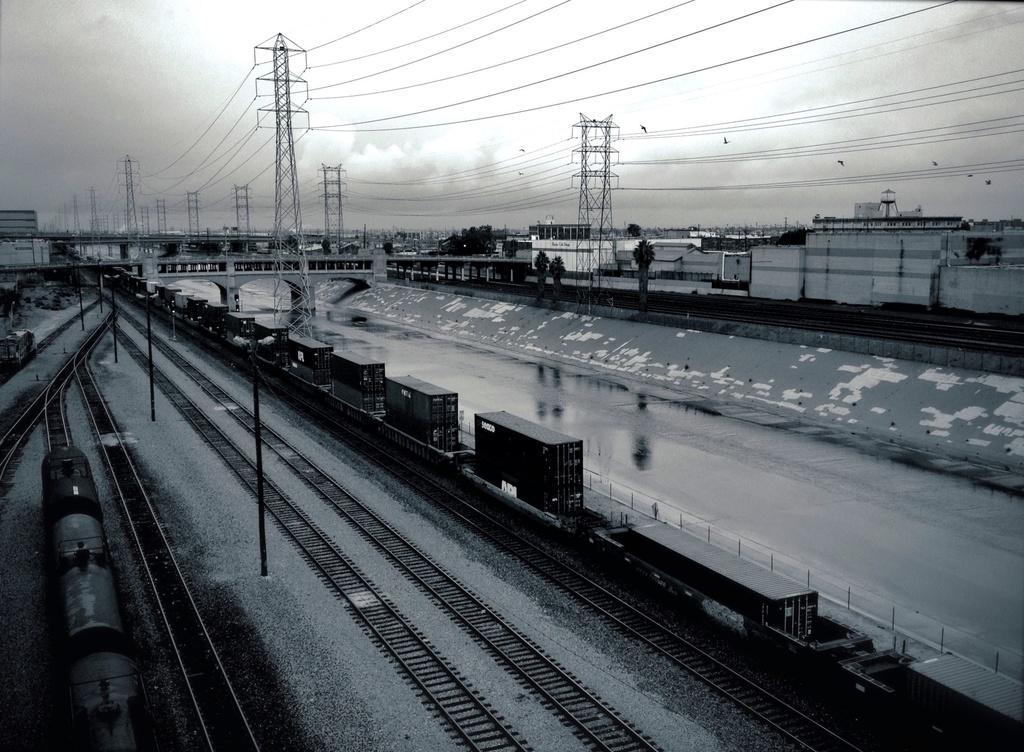In one or two sentences, can you explain what this image depicts? In the picture there are few railway tracks and there are two trains moving on the different tracks, on the right side there are many towers and a lot of wires are attached to that towers, beside the towers there are few trees and houses. There are some birds sitting on the wires. 